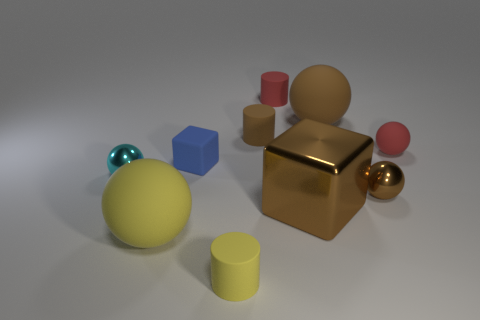There is a yellow matte object on the right side of the blue rubber cube; is its size the same as the brown thing on the left side of the large cube?
Ensure brevity in your answer.  Yes. The small brown object that is the same material as the red cylinder is what shape?
Your response must be concise. Cylinder. Is there any other thing that is the same shape as the tiny yellow matte thing?
Ensure brevity in your answer.  Yes. What color is the block right of the matte cylinder in front of the red rubber thing that is in front of the brown rubber sphere?
Provide a short and direct response. Brown. Is the number of tiny cylinders behind the red matte cylinder less than the number of matte cubes to the right of the tiny yellow rubber cylinder?
Offer a very short reply. No. Do the tiny yellow thing and the big metal object have the same shape?
Offer a very short reply. No. What number of brown matte objects are the same size as the yellow ball?
Offer a very short reply. 1. Is the number of blue blocks that are behind the tiny brown matte cylinder less than the number of small blue matte blocks?
Make the answer very short. Yes. What is the size of the block that is to the left of the tiny cylinder that is in front of the brown metallic cube?
Keep it short and to the point. Small. What number of things are either small rubber objects or cyan spheres?
Offer a very short reply. 6. 